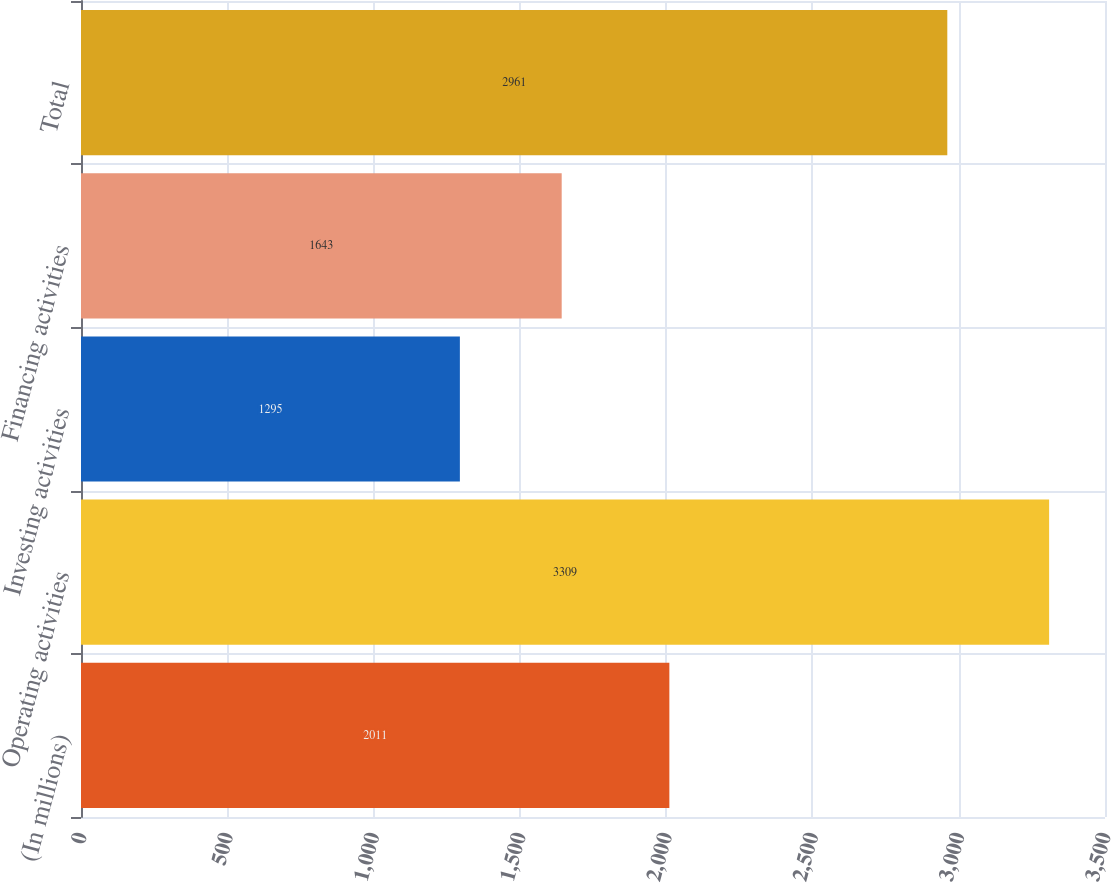<chart> <loc_0><loc_0><loc_500><loc_500><bar_chart><fcel>(In millions)<fcel>Operating activities<fcel>Investing activities<fcel>Financing activities<fcel>Total<nl><fcel>2011<fcel>3309<fcel>1295<fcel>1643<fcel>2961<nl></chart> 